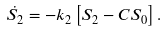Convert formula to latex. <formula><loc_0><loc_0><loc_500><loc_500>\dot { S _ { 2 } } = - k _ { 2 } \left [ S _ { 2 } - C S _ { 0 } \right ] .</formula> 